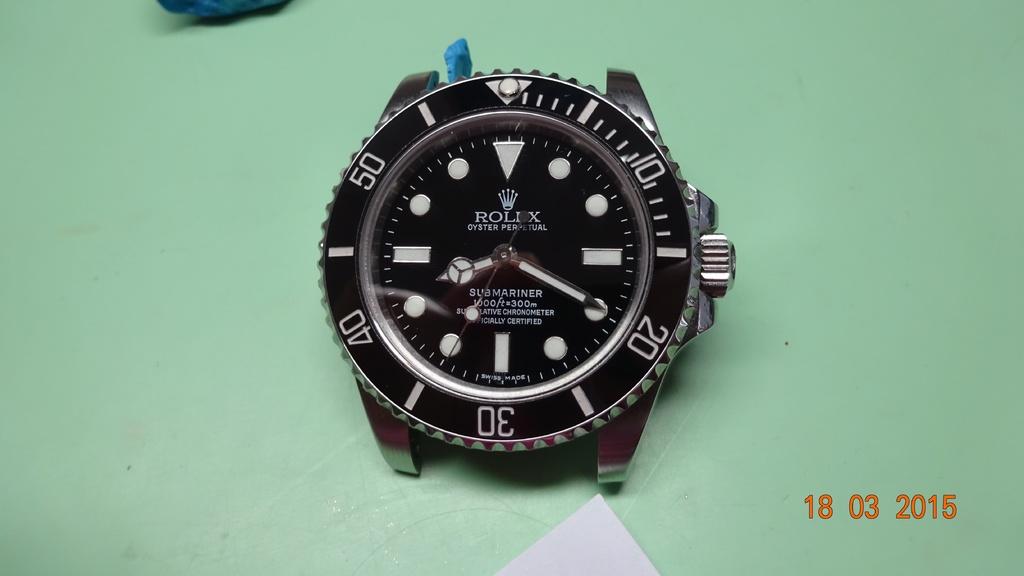When was this taken?
Keep it short and to the point. 18 03 2015. What brand of watch?
Your answer should be compact. Rolex. 